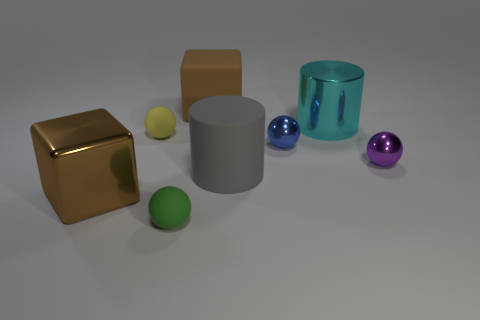Does the shiny cube have the same color as the matte cube?
Your answer should be compact. Yes. Are there any yellow spheres of the same size as the matte cube?
Your answer should be compact. No. There is a cylinder that is in front of the small object right of the tiny blue shiny sphere; what is its size?
Ensure brevity in your answer.  Large. How many large metal cubes have the same color as the large matte block?
Your answer should be very brief. 1. The shiny object in front of the large cylinder that is in front of the big cyan metallic cylinder is what shape?
Offer a very short reply. Cube. How many other objects have the same material as the cyan object?
Offer a very short reply. 3. What material is the brown cube left of the big rubber cube?
Your answer should be compact. Metal. What shape is the object that is in front of the large block that is in front of the brown cube that is behind the small yellow matte ball?
Your answer should be very brief. Sphere. Do the rubber ball in front of the large brown shiny cube and the ball to the right of the big cyan metallic cylinder have the same color?
Offer a very short reply. No. Are there fewer cyan cylinders that are behind the big cyan object than shiny objects in front of the purple object?
Make the answer very short. Yes. 